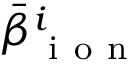<formula> <loc_0><loc_0><loc_500><loc_500>\bar { \beta } _ { i o n } ^ { i }</formula> 